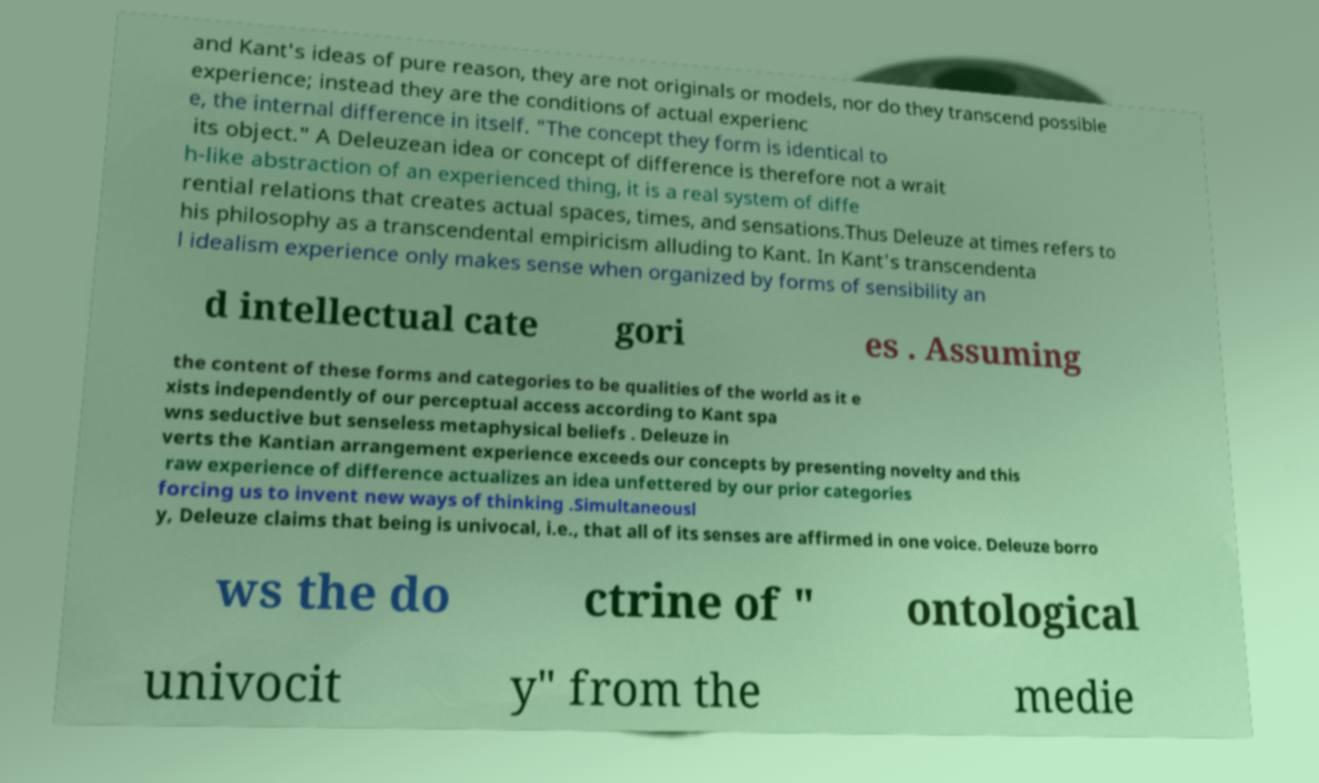I need the written content from this picture converted into text. Can you do that? and Kant's ideas of pure reason, they are not originals or models, nor do they transcend possible experience; instead they are the conditions of actual experienc e, the internal difference in itself. "The concept they form is identical to its object." A Deleuzean idea or concept of difference is therefore not a wrait h-like abstraction of an experienced thing, it is a real system of diffe rential relations that creates actual spaces, times, and sensations.Thus Deleuze at times refers to his philosophy as a transcendental empiricism alluding to Kant. In Kant's transcendenta l idealism experience only makes sense when organized by forms of sensibility an d intellectual cate gori es . Assuming the content of these forms and categories to be qualities of the world as it e xists independently of our perceptual access according to Kant spa wns seductive but senseless metaphysical beliefs . Deleuze in verts the Kantian arrangement experience exceeds our concepts by presenting novelty and this raw experience of difference actualizes an idea unfettered by our prior categories forcing us to invent new ways of thinking .Simultaneousl y, Deleuze claims that being is univocal, i.e., that all of its senses are affirmed in one voice. Deleuze borro ws the do ctrine of " ontological univocit y" from the medie 